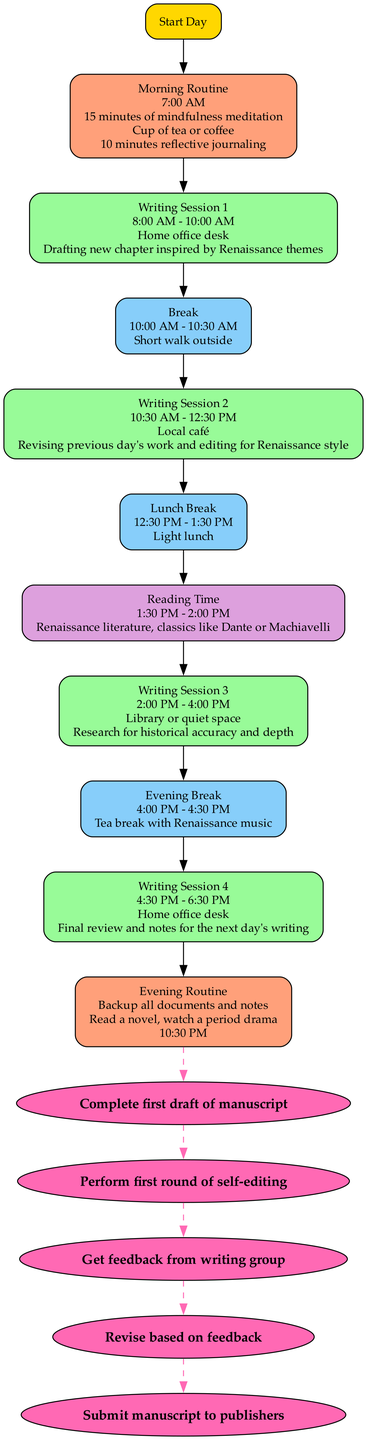What time does the first writing session start? The diagram indicates that the first writing session begins at 8:00 AM, as specified in the Writing Session 1 node.
Answer: 8:00 AM What is the activity during the lunch break? According to the Lunch Break node, the activity is a light lunch, which is directly mentioned in the diagram.
Answer: Light lunch How many writing sessions are included in the diagram? The diagram lists a total of four distinct writing sessions. By counting the Writing Session nodes, it shows Writing Session 1, 2, 3, and 4.
Answer: 4 What follows the first writing session? The first writing session is followed by a break, which is indicated by the edge connecting Writing Session 1 to Break 1.
Answer: Break What is the purpose of the reading time in the afternoon routine? The afternoon routine's reading time node specifies that its purpose is to immerse in Renaissance language and themes, providing a clear purpose linked to the reading activity.
Answer: Immerse in Renaissance language and themes When is the final draft milestone reached? The final draft milestone is reached after the peer review milestone, as indicated by the dashed edges connecting the milestones in the diagram. Therefore, it follows that before reaching Final Draft, Peer Review must be completed.
Answer: After Peer Review Where does the writer usually conduct the second writing session? The second writing session is conducted at a local café, as detailed in the Writing Session 2 node, which includes the location information.
Answer: Local café What is the sync work task at the end of the day? The sync work task at the end of the day is to backup all documents and notes, which is clearly mentioned in the End of Day Routine node.
Answer: Backup all documents and notes What is the suggested time for morning meditation? The morning routine specifies that the suggested time for meditation is 15 minutes, as stated directly in the Morning Routine node.
Answer: 15 minutes 